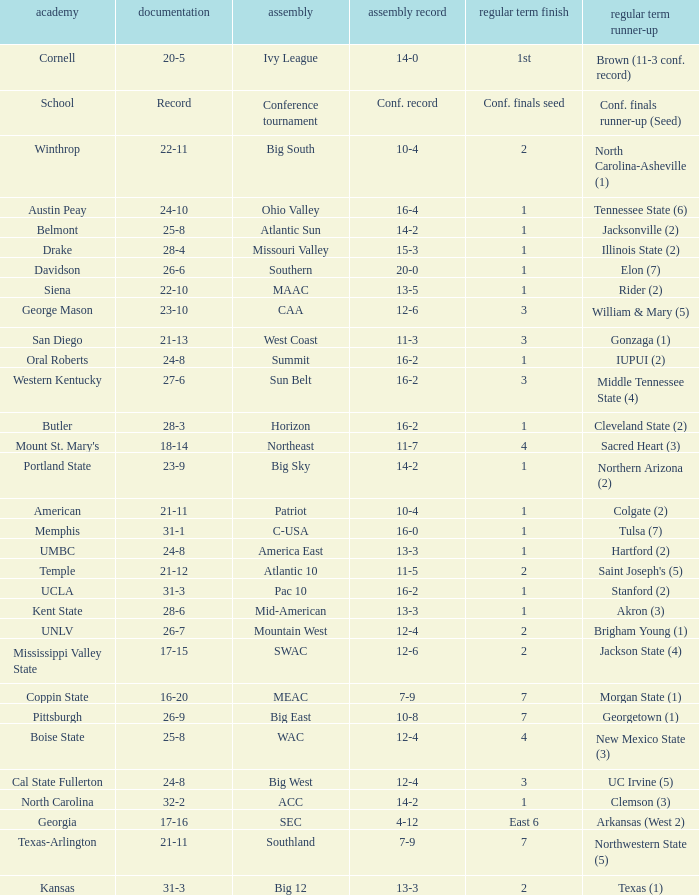For teams in the Sun Belt conference, what is the conference record? 16-2. 